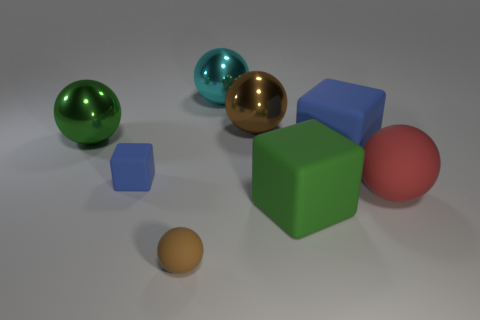Are there any large brown metallic objects that are on the right side of the blue cube that is right of the brown object that is to the right of the big cyan ball?
Your response must be concise. No. What color is the tiny rubber thing that is the same shape as the cyan metal object?
Give a very brief answer. Brown. What number of yellow objects are either balls or rubber cubes?
Ensure brevity in your answer.  0. What is the blue thing to the left of the blue cube that is right of the cyan metallic object made of?
Offer a very short reply. Rubber. Do the small blue thing and the large blue object have the same shape?
Provide a succinct answer. Yes. What color is the other rubber cube that is the same size as the green matte block?
Provide a succinct answer. Blue. Are there any metal things that have the same color as the tiny sphere?
Offer a terse response. Yes. Is there a big green cube?
Keep it short and to the point. Yes. Is the brown object that is in front of the large green sphere made of the same material as the green cube?
Offer a very short reply. Yes. What size is the thing that is the same color as the small sphere?
Your answer should be compact. Large. 